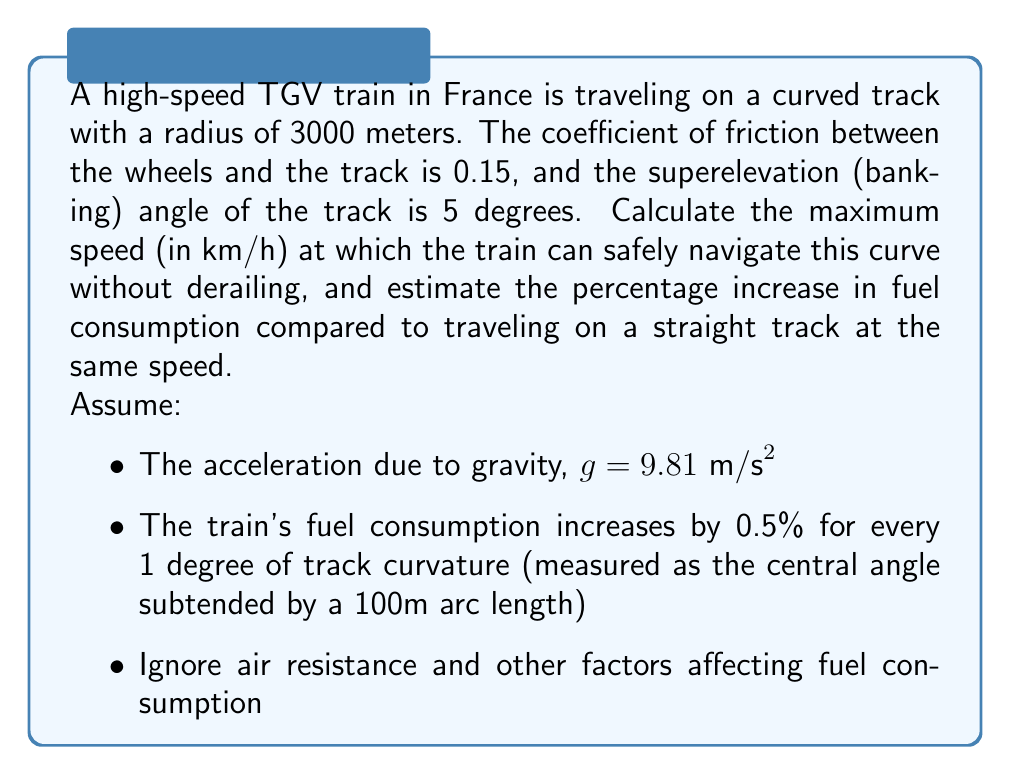Help me with this question. To solve this problem, we'll follow these steps:

1. Calculate the maximum speed for safe cornering
2. Convert the speed to km/h
3. Calculate the track curvature and estimate the fuel consumption increase

Step 1: Calculate the maximum speed for safe cornering

The maximum speed for safe cornering is determined by the balance of centripetal force and the combination of friction and banking forces. We'll use the formula:

$$v_{max} = \sqrt{g R (\mu \cos \theta + \sin \theta)}$$

Where:
$v_{max}$ is the maximum speed (m/s)
$g$ is the acceleration due to gravity (9.81 m/s²)
$R$ is the radius of the curve (3000 m)
$\mu$ is the coefficient of friction (0.15)
$\theta$ is the superelevation angle (5 degrees)

First, convert the angle to radians:
$$\theta = 5° \times \frac{\pi}{180°} = 0.0873 \text{ radians}$$

Now, let's substitute the values into the formula:

$$\begin{align}
v_{max} &= \sqrt{9.81 \times 3000 \times (0.15 \times \cos(0.0873) + \sin(0.0873))} \\
&= \sqrt{29430 \times (0.15 \times 0.9962 + 0.0872)} \\
&= \sqrt{29430 \times 0.2366} \\
&= \sqrt{6965.14} \\
&= 83.46 \text{ m/s}
\end{align}$$

Step 2: Convert the speed to km/h

To convert m/s to km/h, multiply by 3600/1000:

$$83.46 \text{ m/s} \times \frac{3600}{1000} = 300.46 \text{ km/h}$$

Step 3: Calculate the track curvature and estimate the fuel consumption increase

The central angle subtended by a 100m arc length on this curve can be calculated using the formula:

$$\theta = \frac{s}{R} \times \frac{180°}{\pi}$$

Where:
$\theta$ is the central angle in degrees
$s$ is the arc length (100 m)
$R$ is the radius of the curve (3000 m)

$$\begin{align}
\theta &= \frac{100}{3000} \times \frac{180°}{\pi} \\
&= 0.0333 \times \frac{180°}{\pi} \\
&= 1.91°
\end{align}$$

The fuel consumption increase is 0.5% per degree of curvature, so:

$$1.91° \times 0.5\%/° = 0.955\% \approx 0.96\%$$

Therefore, the fuel consumption increases by approximately 0.96% compared to traveling on a straight track at the same speed.
Answer: The maximum safe speed for the TGV train on the curved track is 300.46 km/h, and the estimated increase in fuel consumption compared to traveling on a straight track at the same speed is 0.96%. 